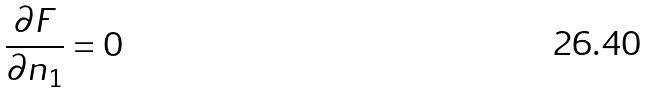Convert formula to latex. <formula><loc_0><loc_0><loc_500><loc_500>\frac { \partial F } { \partial n _ { 1 } } = 0</formula> 